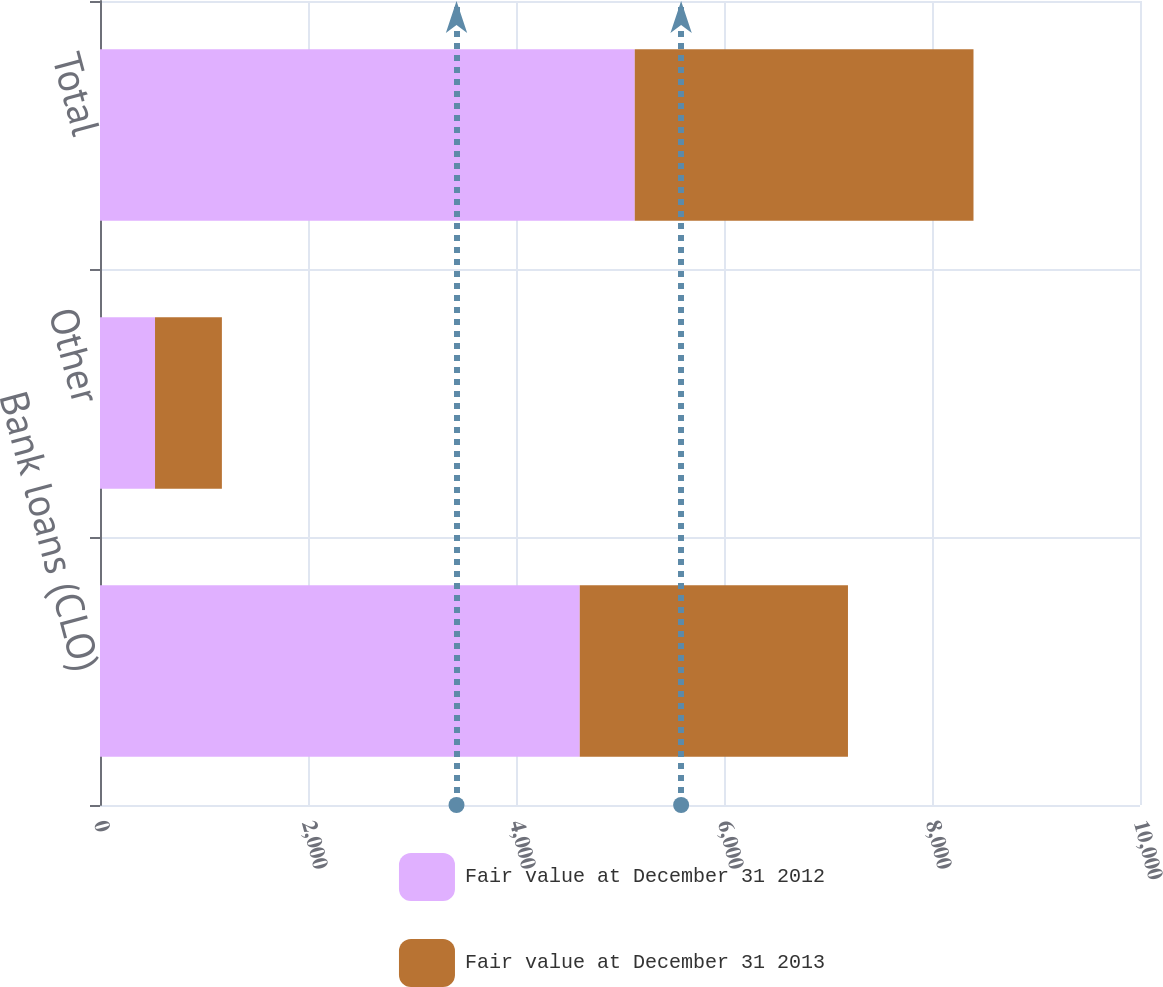<chart> <loc_0><loc_0><loc_500><loc_500><stacked_bar_chart><ecel><fcel>Bank loans (CLO)<fcel>Other<fcel>Total<nl><fcel>Fair value at December 31 2012<fcel>4613<fcel>529<fcel>5142<nl><fcel>Fair value at December 31 2013<fcel>2579<fcel>643<fcel>3257<nl></chart> 